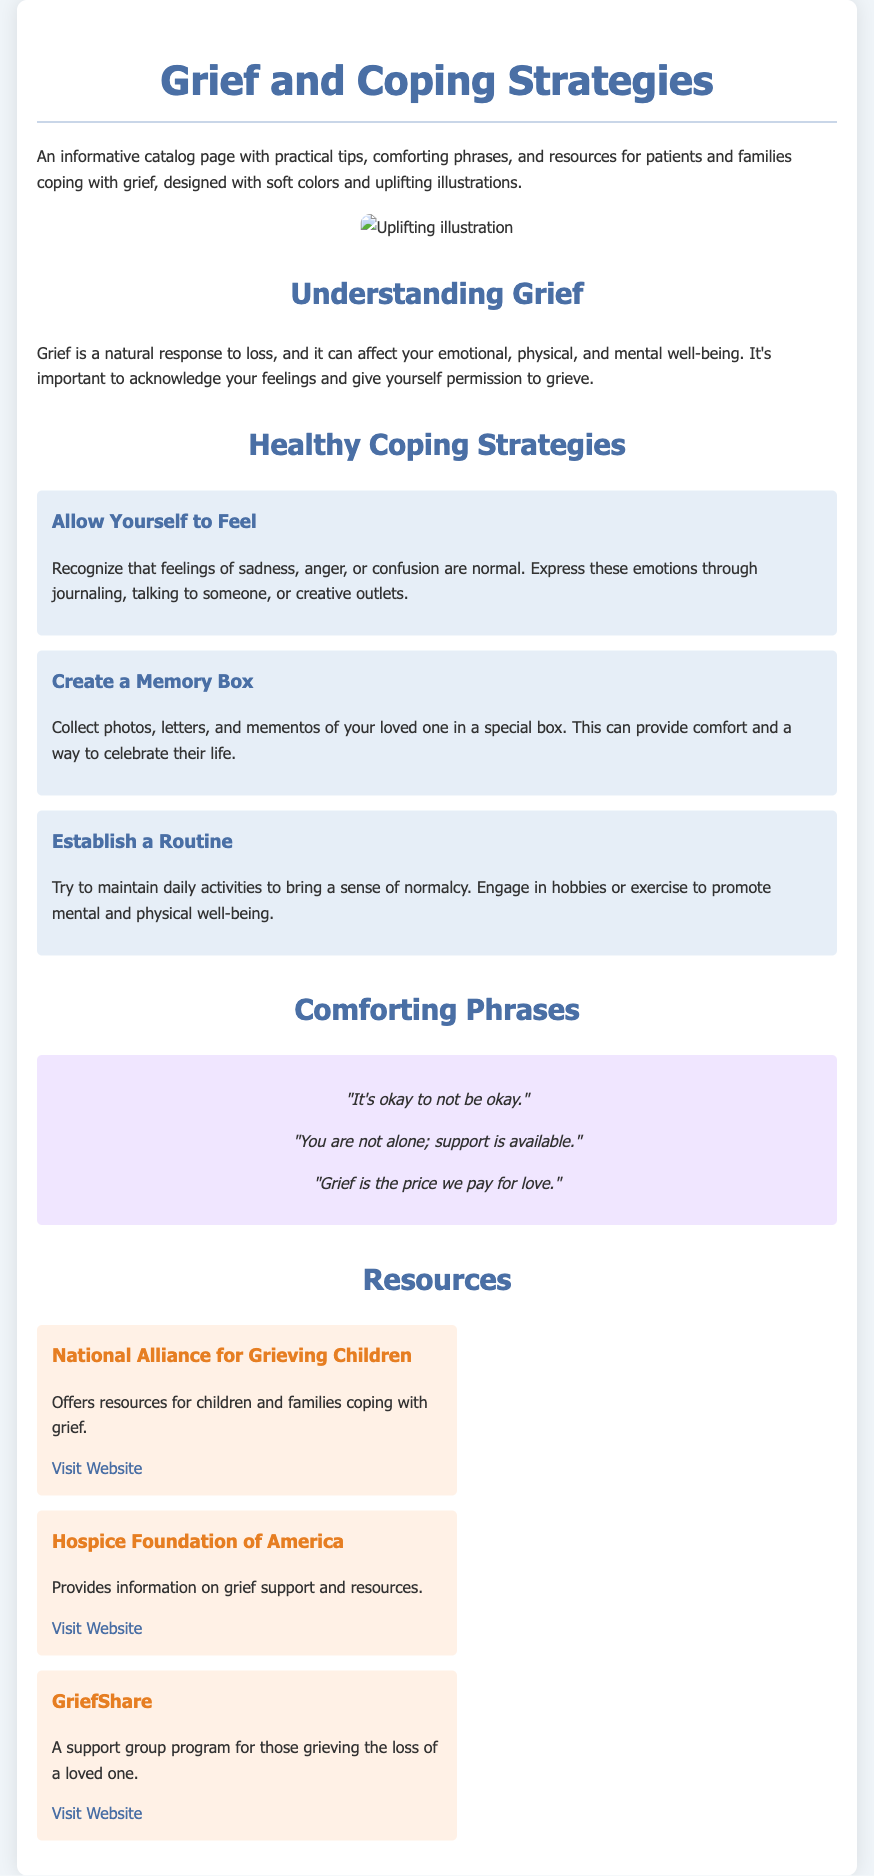What is the title of the pamphlet? The title of the pamphlet is clearly stated at the top of the document.
Answer: Grief and Coping Strategies How many coping strategies are listed? The document lists three distinct coping strategies under the Healthy Coping Strategies section.
Answer: 3 What is one comforting phrase mentioned? One of the comforting phrases can be found in the Comforting Phrases section, highlighting emotional support.
Answer: "It's okay to not be okay." What organization offers resources for children coping with grief? The document provides the name of an organization that specializes in supporting children in grief.
Answer: National Alliance for Grieving Children What background color is used for the tip sections? The background color for the tip sections is specified in the design styles of the document.
Answer: #e6eef7 What type of emotional response is grief categorized as? The document describes grief in terms of its emotional impact, suggesting it is a natural response.
Answer: Natural response What image style is present in the illustration section? The illustration section should have images that convey a specific artistic quality, noted in the description.
Answer: Uplifting illustrations 